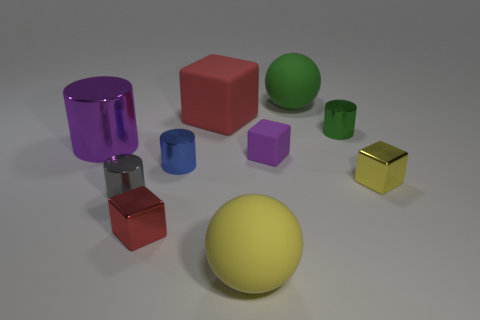There is a rubber sphere that is behind the big red cube; does it have the same size as the red thing behind the red metal block?
Your response must be concise. Yes. There is a yellow object that is left of the tiny yellow shiny thing; what is its shape?
Provide a succinct answer. Sphere. The big matte block is what color?
Ensure brevity in your answer.  Red. There is a red matte cube; is its size the same as the rubber sphere that is in front of the tiny red metal cube?
Keep it short and to the point. Yes. How many metallic objects are big green objects or small blocks?
Your response must be concise. 2. There is a large cylinder; is it the same color as the rubber cube that is right of the yellow matte ball?
Provide a succinct answer. Yes. What shape is the small purple thing?
Keep it short and to the point. Cube. There is a cylinder on the left side of the tiny cylinder on the left side of the small block on the left side of the purple block; what is its size?
Your answer should be compact. Large. What number of other things are the same shape as the tiny yellow thing?
Give a very brief answer. 3. Is the shape of the big rubber thing in front of the small blue cylinder the same as the green thing that is behind the big red block?
Your response must be concise. Yes. 